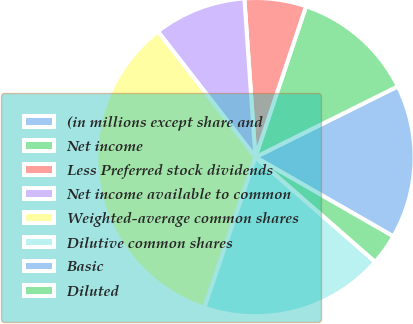<chart> <loc_0><loc_0><loc_500><loc_500><pie_chart><fcel>(in millions except share and<fcel>Net income<fcel>Less Preferred stock dividends<fcel>Net income available to common<fcel>Weighted-average common shares<fcel>Dilutive common shares<fcel>Basic<fcel>Diluted<nl><fcel>15.64%<fcel>12.51%<fcel>6.26%<fcel>9.39%<fcel>34.3%<fcel>18.77%<fcel>0.0%<fcel>3.13%<nl></chart> 